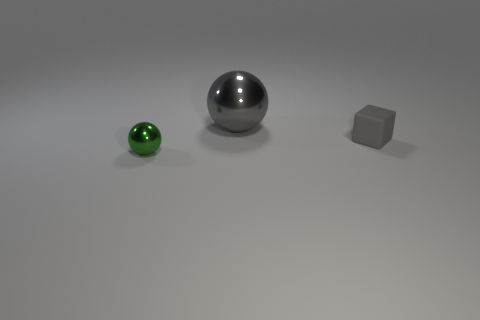There is a thing behind the gray rubber object; is it the same shape as the small gray rubber thing?
Your answer should be compact. No. Is there anything else that has the same material as the small green object?
Your response must be concise. Yes. How many objects are either small cyan cylinders or spheres right of the green metallic object?
Your response must be concise. 1. How big is the thing that is in front of the large shiny thing and behind the tiny shiny thing?
Ensure brevity in your answer.  Small. Is the number of tiny green things that are in front of the small shiny object greater than the number of big metal objects that are right of the cube?
Make the answer very short. No. Does the large metallic thing have the same shape as the tiny object that is on the right side of the green object?
Your answer should be compact. No. What number of other objects are there of the same shape as the big object?
Make the answer very short. 1. What is the color of the object that is both behind the tiny shiny sphere and to the left of the rubber block?
Your answer should be compact. Gray. What color is the tiny block?
Give a very brief answer. Gray. Are the green ball and the gray object that is left of the small gray rubber object made of the same material?
Provide a succinct answer. Yes. 